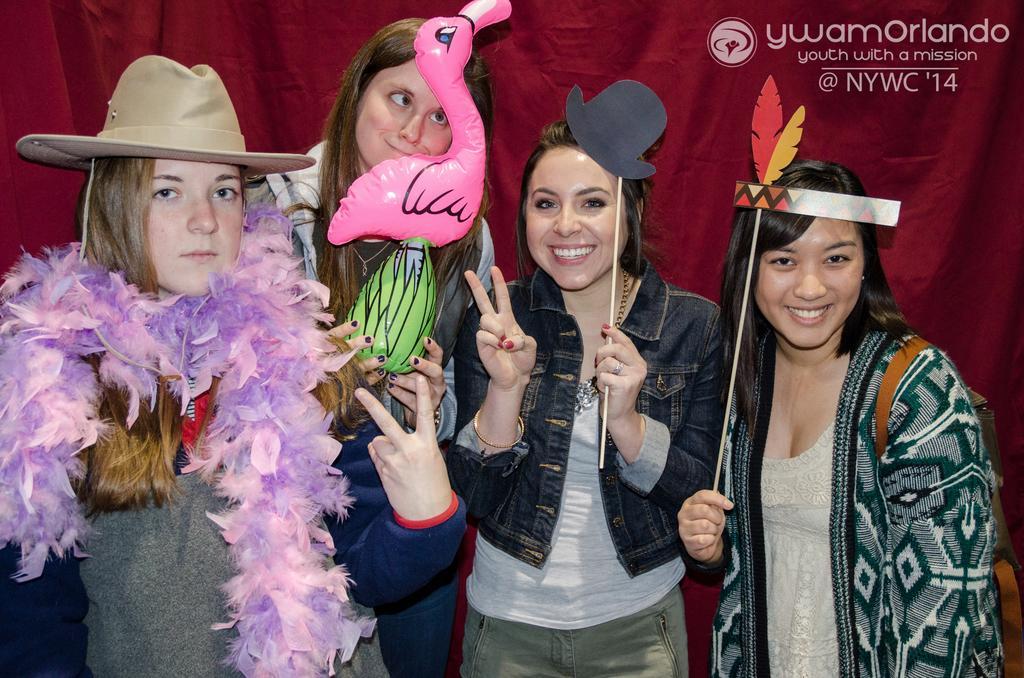Can you describe this image briefly? In this image we can see four people, three of them are holding some objects, a lady is wearing a scarf, and a hat, also we can see a red color curtain behind them, and there is a text on the image. 